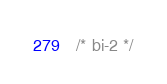<code> <loc_0><loc_0><loc_500><loc_500><_SQL_>/* bi-2 */
</code> 